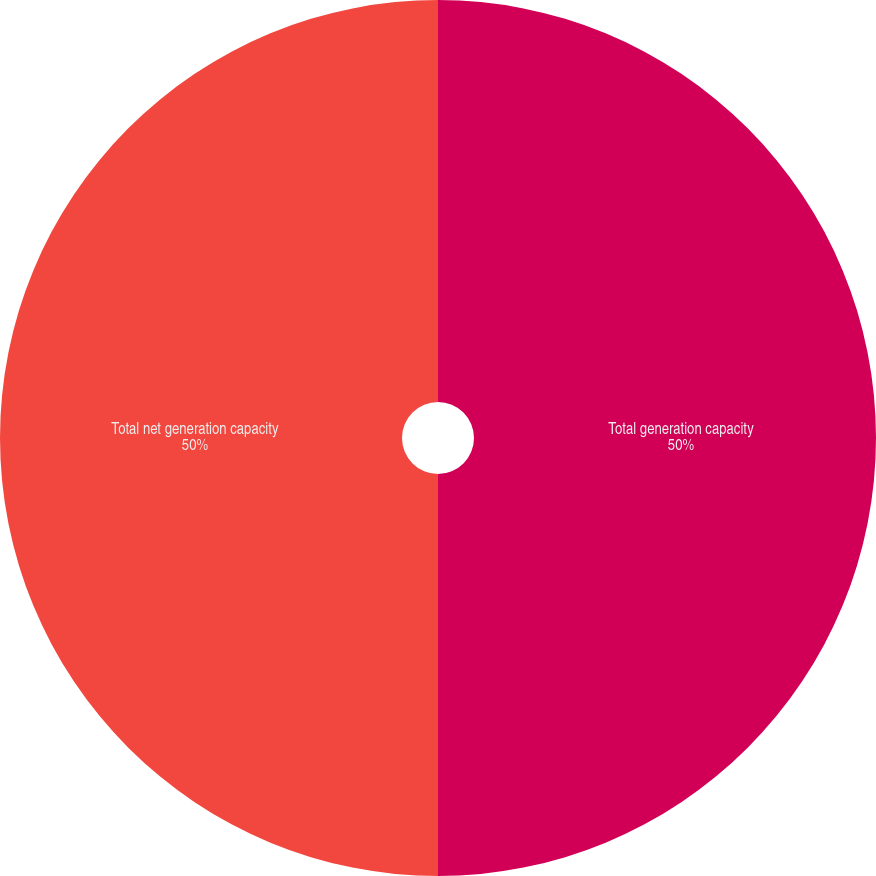Convert chart. <chart><loc_0><loc_0><loc_500><loc_500><pie_chart><fcel>Total generation capacity<fcel>Total net generation capacity<nl><fcel>50.0%<fcel>50.0%<nl></chart> 